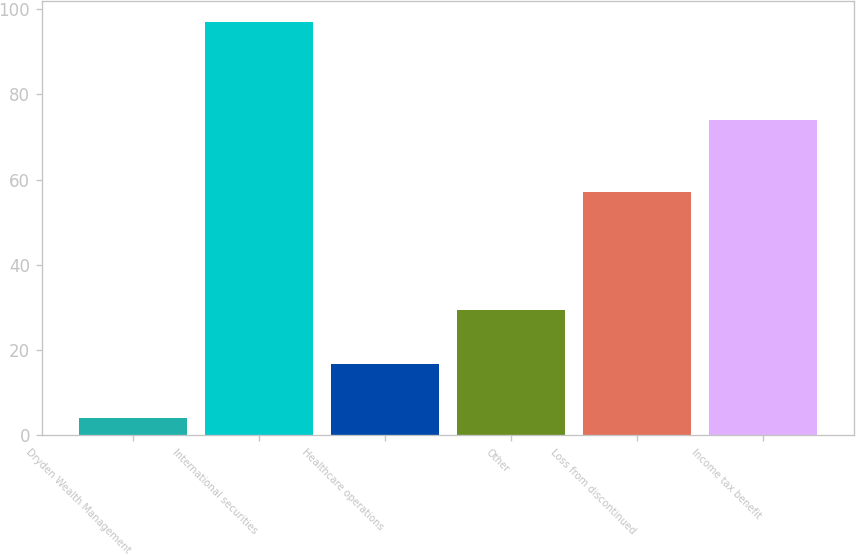Convert chart to OTSL. <chart><loc_0><loc_0><loc_500><loc_500><bar_chart><fcel>Dryden Wealth Management<fcel>International securities<fcel>Healthcare operations<fcel>Other<fcel>Loss from discontinued<fcel>Income tax benefit<nl><fcel>4<fcel>97<fcel>16.7<fcel>29.4<fcel>57<fcel>74<nl></chart> 